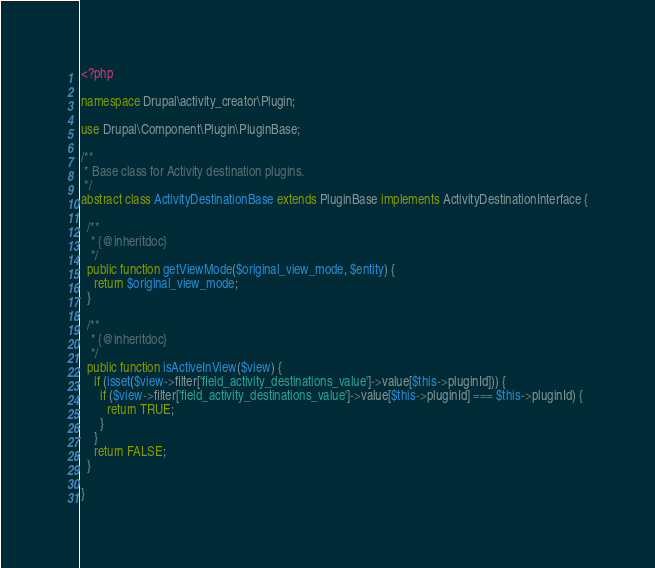<code> <loc_0><loc_0><loc_500><loc_500><_PHP_><?php

namespace Drupal\activity_creator\Plugin;

use Drupal\Component\Plugin\PluginBase;

/**
 * Base class for Activity destination plugins.
 */
abstract class ActivityDestinationBase extends PluginBase implements ActivityDestinationInterface {

  /**
   * {@inheritdoc}
   */
  public function getViewMode($original_view_mode, $entity) {
    return $original_view_mode;
  }

  /**
   * {@inheritdoc}
   */
  public function isActiveInView($view) {
    if (isset($view->filter['field_activity_destinations_value']->value[$this->pluginId])) {
      if ($view->filter['field_activity_destinations_value']->value[$this->pluginId] === $this->pluginId) {
        return TRUE;
      }
    }
    return FALSE;
  }

}
</code> 